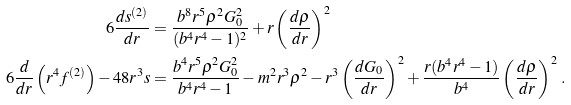<formula> <loc_0><loc_0><loc_500><loc_500>6 \frac { d s ^ { ( 2 ) } } { d r } & = \frac { b ^ { 8 } r ^ { 5 } \rho ^ { 2 } G _ { 0 } ^ { 2 } } { ( b ^ { 4 } r ^ { 4 } - 1 ) ^ { 2 } } + r \left ( \frac { d \rho } { d r } \right ) ^ { 2 } \\ 6 \frac { d } { d r } \left ( r ^ { 4 } f ^ { ( 2 ) } \right ) - 4 8 r ^ { 3 } s & = \frac { b ^ { 4 } r ^ { 5 } \rho ^ { 2 } G _ { 0 } ^ { 2 } } { b ^ { 4 } r ^ { 4 } - 1 } - m ^ { 2 } r ^ { 3 } \rho ^ { 2 } - r ^ { 3 } \left ( \frac { d G _ { 0 } } { d r } \right ) ^ { 2 } + \frac { r ( b ^ { 4 } r ^ { 4 } - 1 ) } { b ^ { 4 } } \left ( \frac { d \rho } { d r } \right ) ^ { 2 } \, .</formula> 